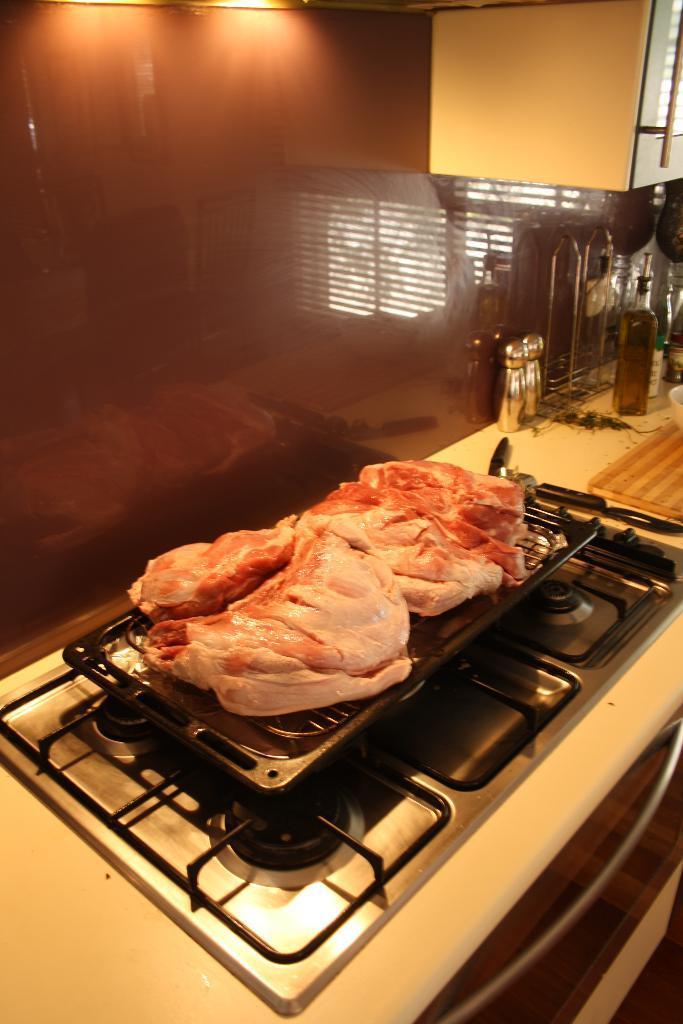Describe this image in one or two sentences. the meat is getting cooked on the stove behind that there are few bottles on the table. 